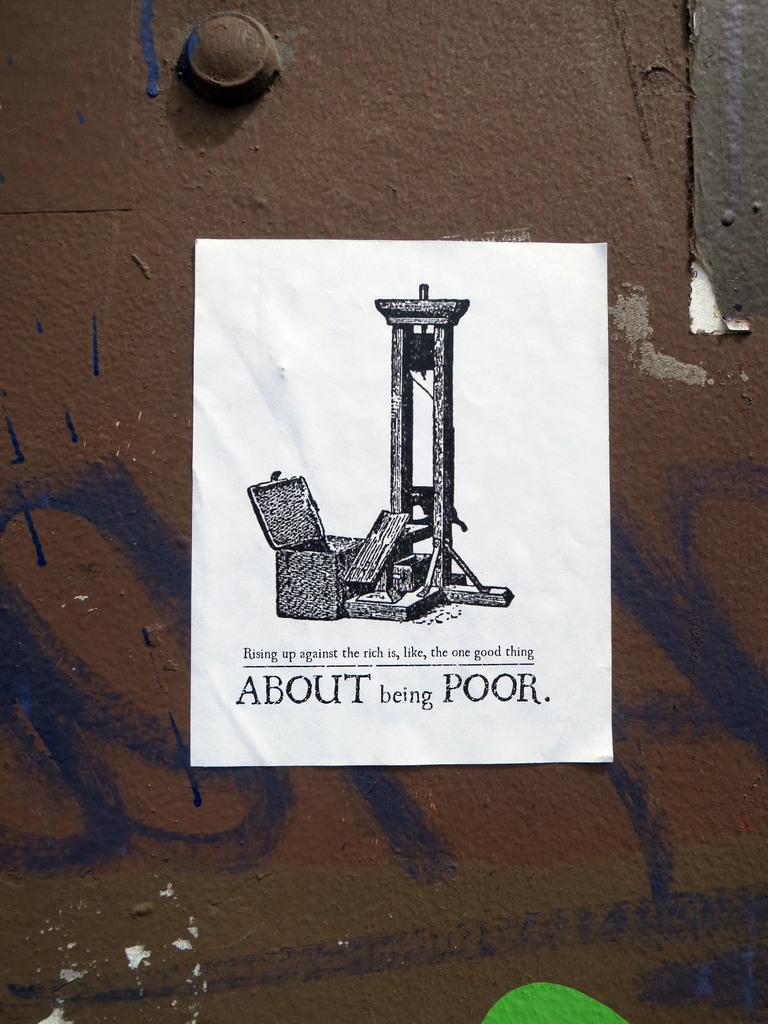What is the title of this poster?
Keep it short and to the point. About being poor. 